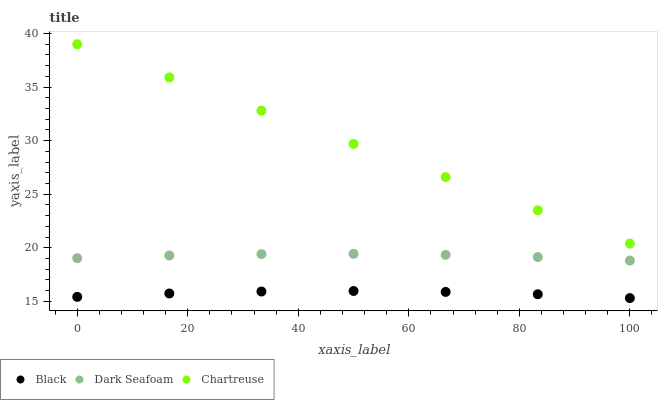Does Black have the minimum area under the curve?
Answer yes or no. Yes. Does Chartreuse have the maximum area under the curve?
Answer yes or no. Yes. Does Chartreuse have the minimum area under the curve?
Answer yes or no. No. Does Black have the maximum area under the curve?
Answer yes or no. No. Is Chartreuse the smoothest?
Answer yes or no. Yes. Is Black the roughest?
Answer yes or no. Yes. Is Black the smoothest?
Answer yes or no. No. Is Chartreuse the roughest?
Answer yes or no. No. Does Black have the lowest value?
Answer yes or no. Yes. Does Chartreuse have the lowest value?
Answer yes or no. No. Does Chartreuse have the highest value?
Answer yes or no. Yes. Does Black have the highest value?
Answer yes or no. No. Is Dark Seafoam less than Chartreuse?
Answer yes or no. Yes. Is Chartreuse greater than Black?
Answer yes or no. Yes. Does Dark Seafoam intersect Chartreuse?
Answer yes or no. No. 